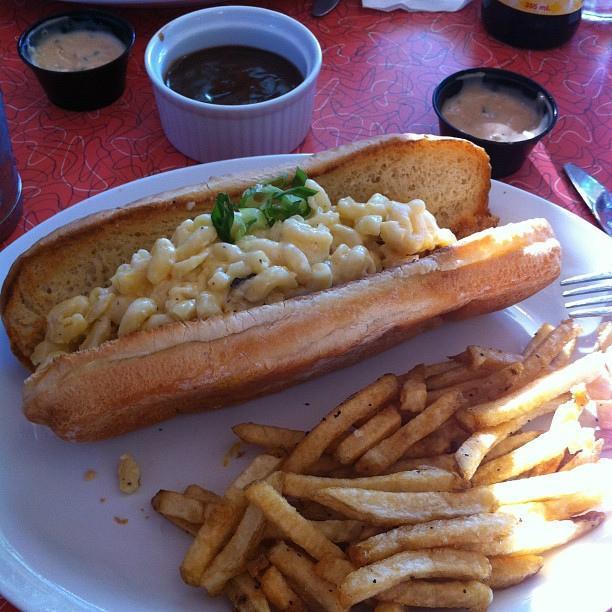How many sauces are there?
Give a very brief answer. 3. How many bowls are in the photo?
Give a very brief answer. 3. How many men are wearing black shorts?
Give a very brief answer. 0. 